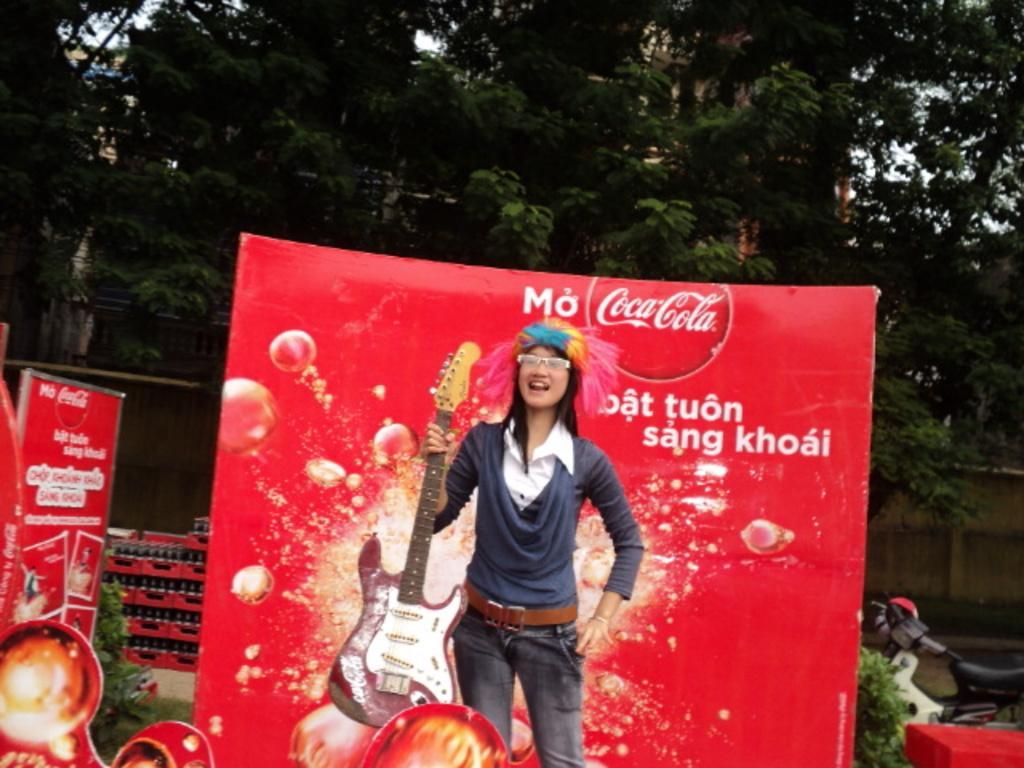Please provide a concise description of this image. As we can see in the image there is a woman who is standing and she is holding a guitar. At the back of her there is a banner on which it's written "Coca Cola" and at the back there are lot of trees. 